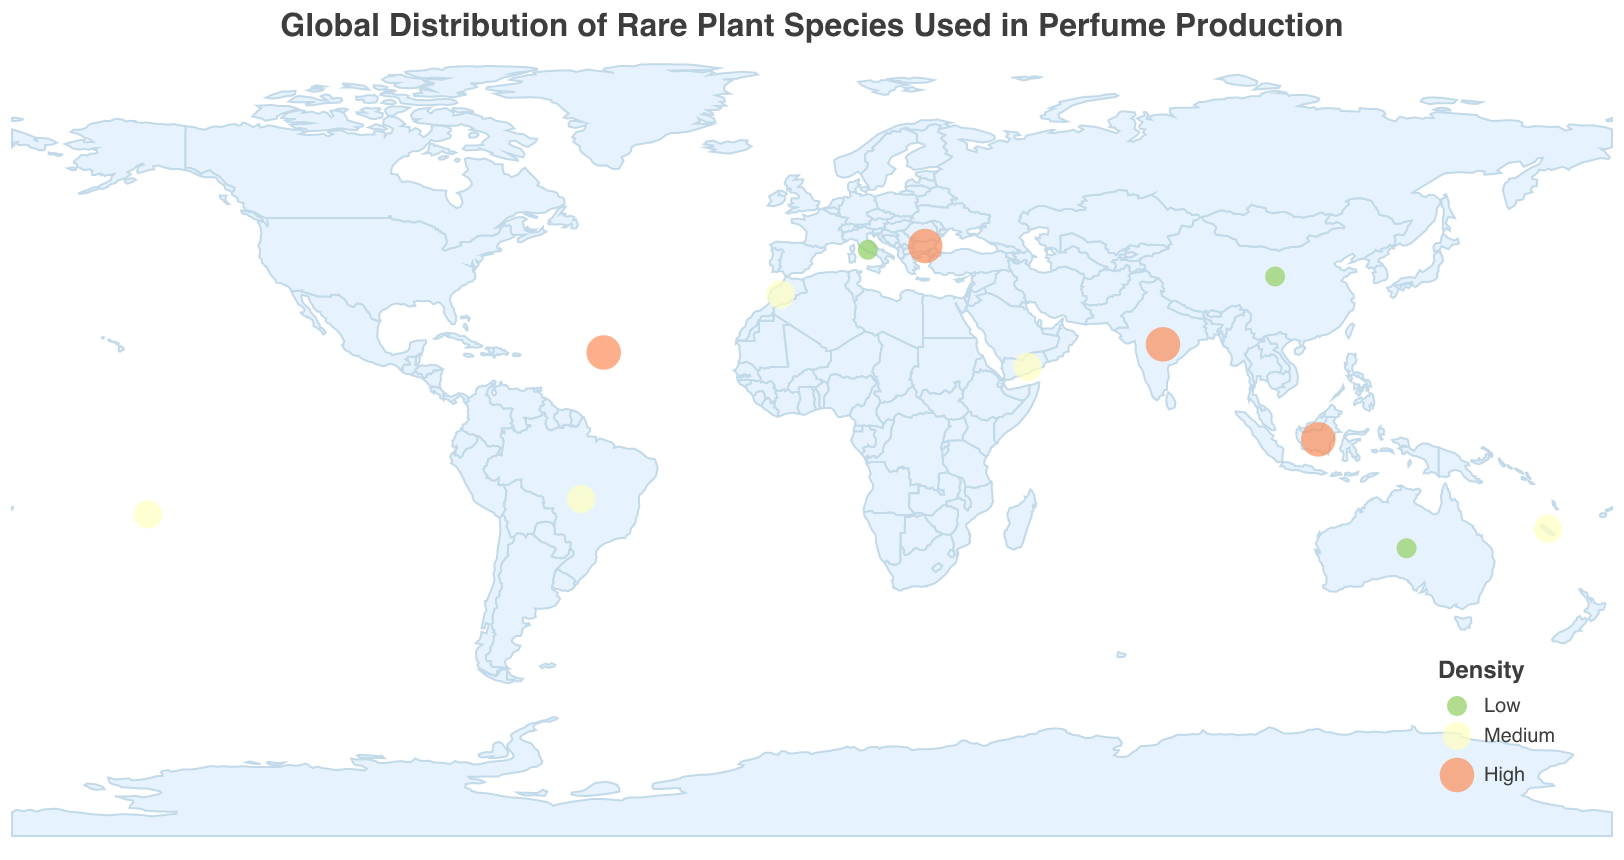What is the title of the figure? The title is displayed at the top of the figure, it reads "Global Distribution of Rare Plant Species Used in Perfume Production"
Answer: Global Distribution of Rare Plant Species Used in Perfume Production How many regions have a high density of rare plant species? Count the regions marked with the color associated with high density. There are Madagascar, India, Indonesia, and Bulgaria
Answer: 4 Which region with a high density is located in Europe? Look for the region marked as high density within the geographical boundaries of Europe. Bulgaria is the only region in Europe with high density
Answer: Bulgaria What is the notable species in New Caledonia and what is its density level? By locating New Caledonia on the map and referring to the corresponding data point, we can see it has medium density and the notable species is Sandalwood (Santalum austrocaledonicum)
Answer: Sandalwood (Santalum austrocaledonicum), Medium Compare the densities of the regions between Yemen and French Polynesia Refer to the map and color coding to check the density level of both regions. Yemen and French Polynesia both have a medium density
Answer: Same density Which region has the lowest density level in the Southern Hemisphere? Look at the regions in the Southern Hemisphere (latitude < 0) and identify the one with the lowest density. Australia is marked with a low density
Answer: Australia How many unique notable species are there in regions with medium density? Refer to the regions marked as medium density and count the unique notable species listed: Tiare flower, Rosa damascena, Tonka bean, Frankincense, Sandalwood
Answer: 5 What is the total number of regions displayed on the map? Count each unique region represented by markers on the map. There are 12 regions in total
Answer: 12 Which region in Asia has a low density, and what is the notable species found there? Identify regions in Asia with low density and refer to the corresponding notable species. China has a low density and the notable species is Osmanthus fragrans
Answer: China, Osmanthus fragrans 